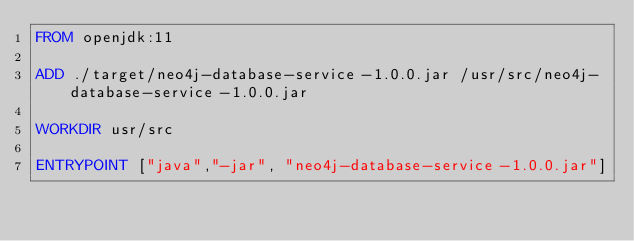Convert code to text. <code><loc_0><loc_0><loc_500><loc_500><_Dockerfile_>FROM openjdk:11

ADD ./target/neo4j-database-service-1.0.0.jar /usr/src/neo4j-database-service-1.0.0.jar

WORKDIR usr/src

ENTRYPOINT ["java","-jar", "neo4j-database-service-1.0.0.jar"]
</code> 